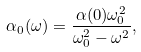Convert formula to latex. <formula><loc_0><loc_0><loc_500><loc_500>\alpha _ { 0 } ( \omega ) = \frac { \alpha ( 0 ) \omega _ { 0 } ^ { 2 } } { \omega _ { 0 } ^ { 2 } - \omega ^ { 2 } } ,</formula> 